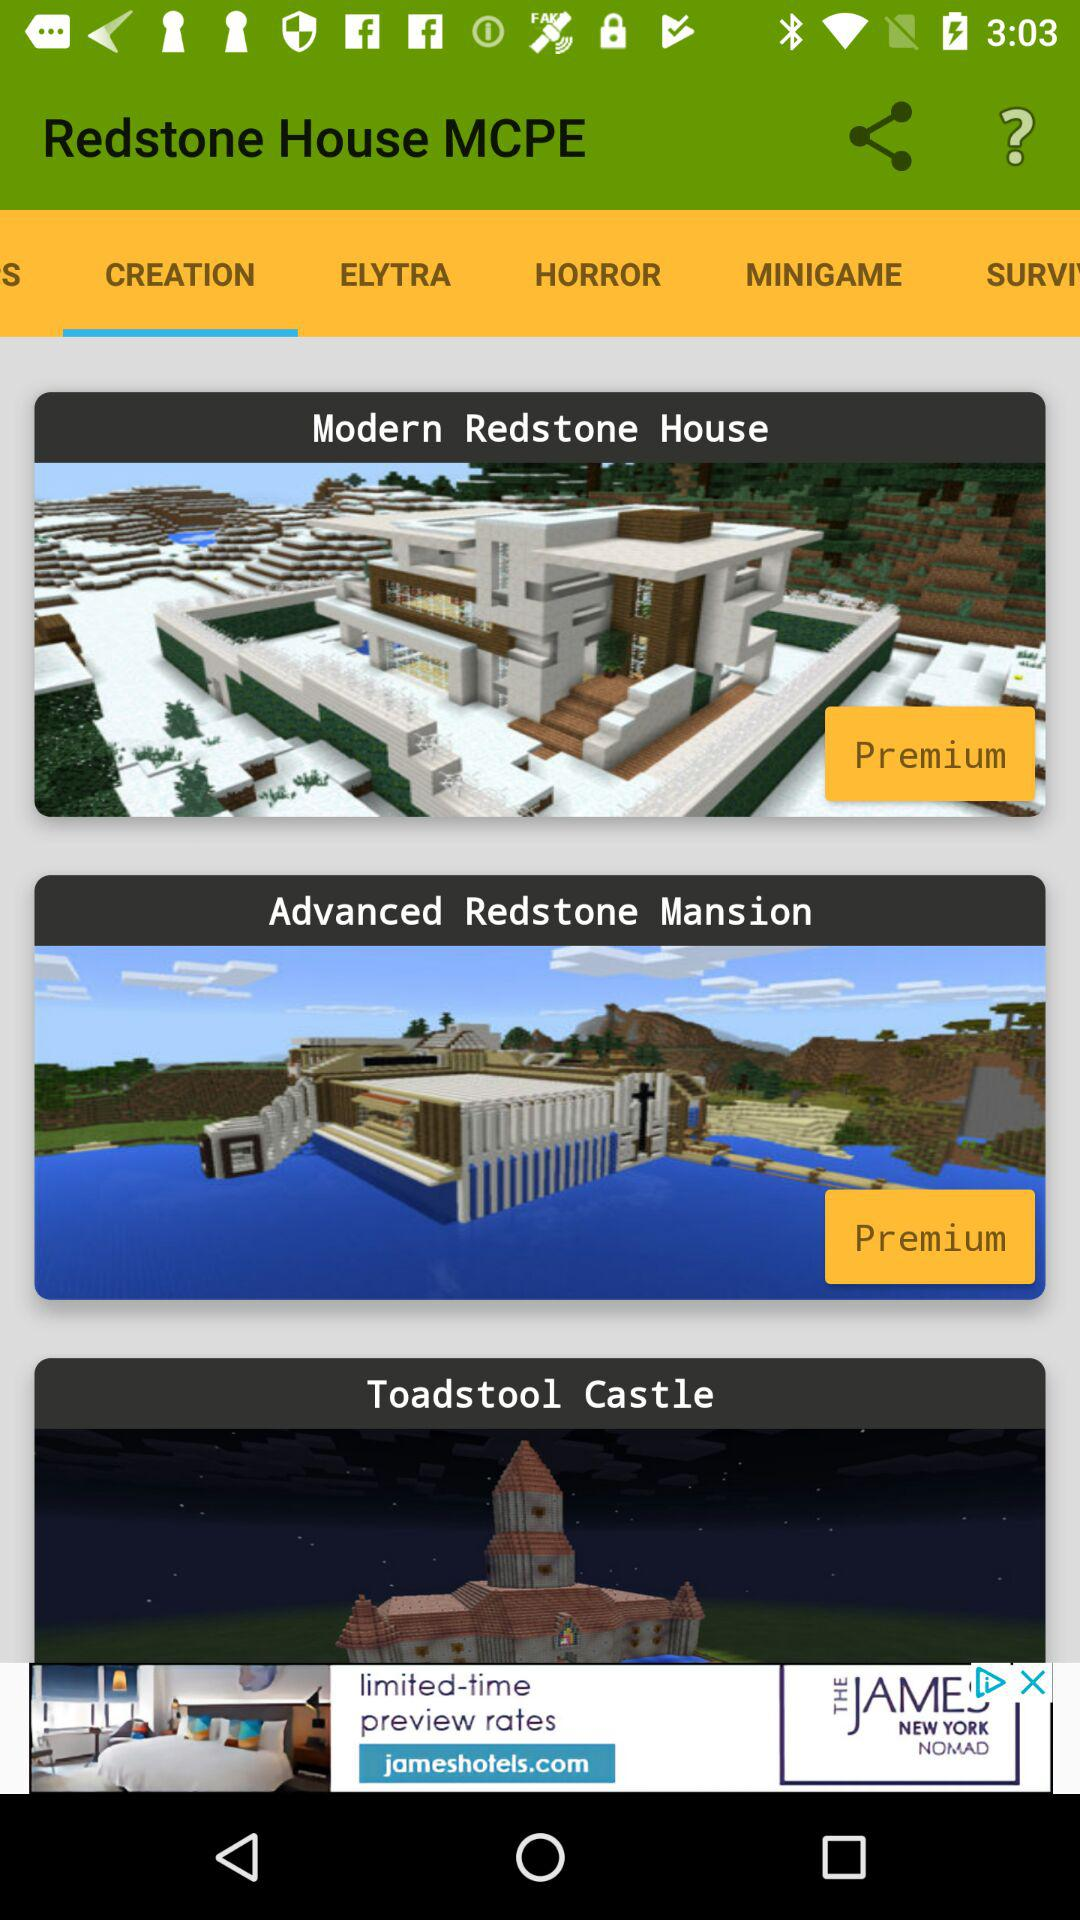Which tab is selected? The selected tab is "CREATION". 